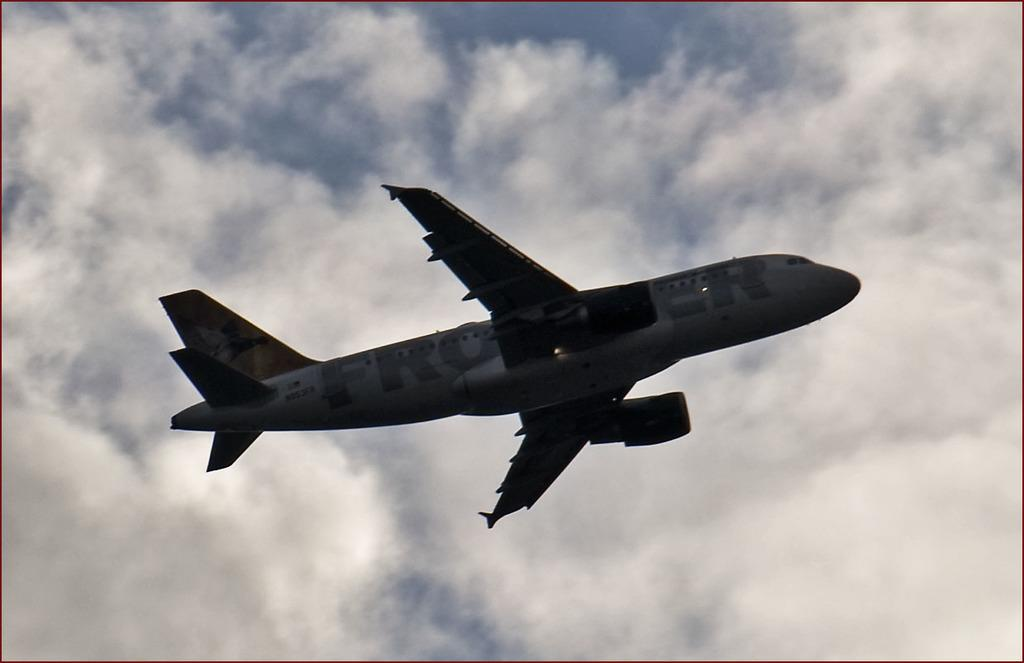<image>
Summarize the visual content of the image. A passenger airplane bearing a word that starts with the letters "FRO" is flying in the sky. 